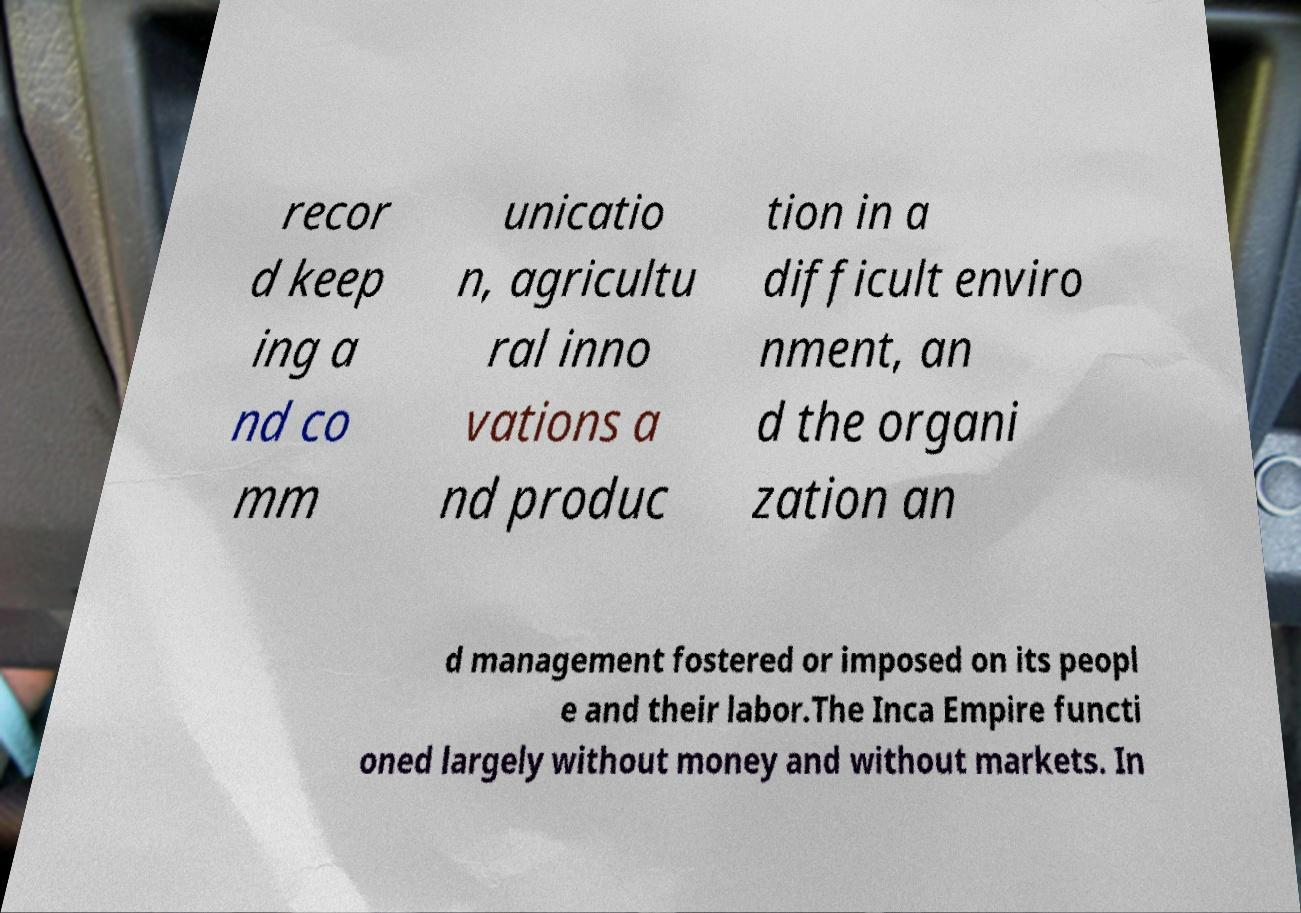Can you accurately transcribe the text from the provided image for me? recor d keep ing a nd co mm unicatio n, agricultu ral inno vations a nd produc tion in a difficult enviro nment, an d the organi zation an d management fostered or imposed on its peopl e and their labor.The Inca Empire functi oned largely without money and without markets. In 